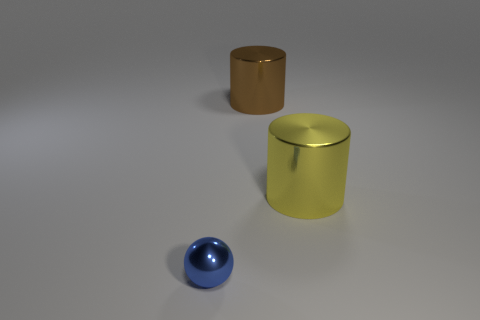Is there anything else that is the same size as the sphere?
Provide a short and direct response. No. Is the number of yellow cylinders less than the number of metal things?
Offer a very short reply. Yes. There is a shiny cylinder that is behind the big metal cylinder that is in front of the brown metallic cylinder; is there a brown cylinder that is in front of it?
Your answer should be compact. No. Is the shape of the thing that is behind the big yellow cylinder the same as  the large yellow shiny thing?
Provide a succinct answer. Yes. Is the number of metallic cylinders that are left of the yellow cylinder greater than the number of small red metal things?
Your response must be concise. Yes. What color is the cylinder that is behind the large metal object on the right side of the metallic cylinder that is left of the large yellow cylinder?
Provide a short and direct response. Brown. Is the size of the blue thing the same as the yellow metallic cylinder?
Your response must be concise. No. What number of blue metal spheres have the same size as the yellow cylinder?
Your response must be concise. 0. Are there any other things that have the same shape as the tiny thing?
Your response must be concise. No. What color is the ball?
Your answer should be compact. Blue. 